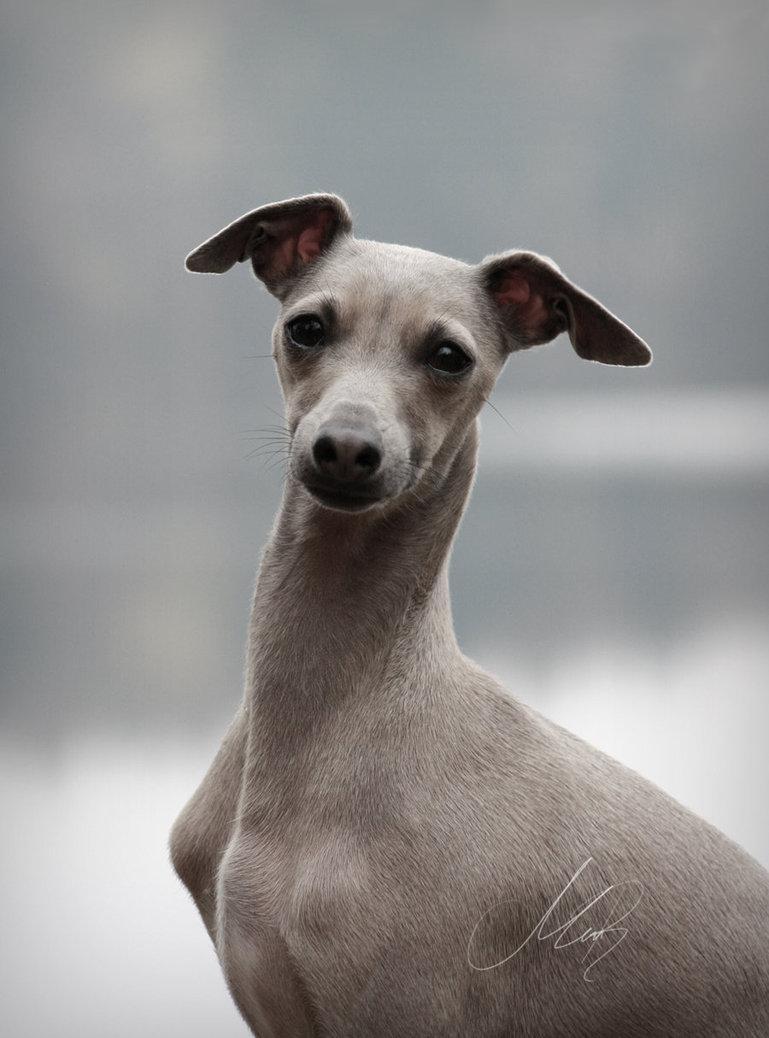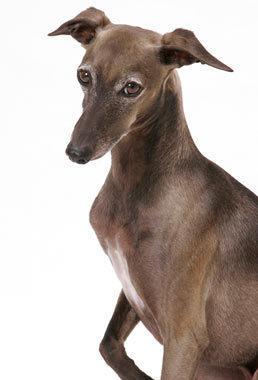The first image is the image on the left, the second image is the image on the right. Analyze the images presented: Is the assertion "One of the dogs has a pink collar." valid? Answer yes or no. No. 